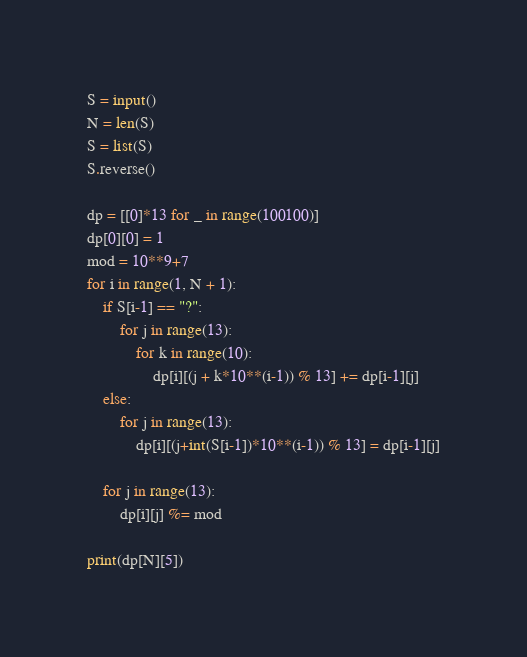Convert code to text. <code><loc_0><loc_0><loc_500><loc_500><_Python_>S = input()
N = len(S)
S = list(S)
S.reverse()

dp = [[0]*13 for _ in range(100100)]
dp[0][0] = 1
mod = 10**9+7
for i in range(1, N + 1):
    if S[i-1] == "?":
        for j in range(13):
            for k in range(10):
                dp[i][(j + k*10**(i-1)) % 13] += dp[i-1][j]
    else:
        for j in range(13):
            dp[i][(j+int(S[i-1])*10**(i-1)) % 13] = dp[i-1][j]

    for j in range(13):
        dp[i][j] %= mod

print(dp[N][5])
</code> 